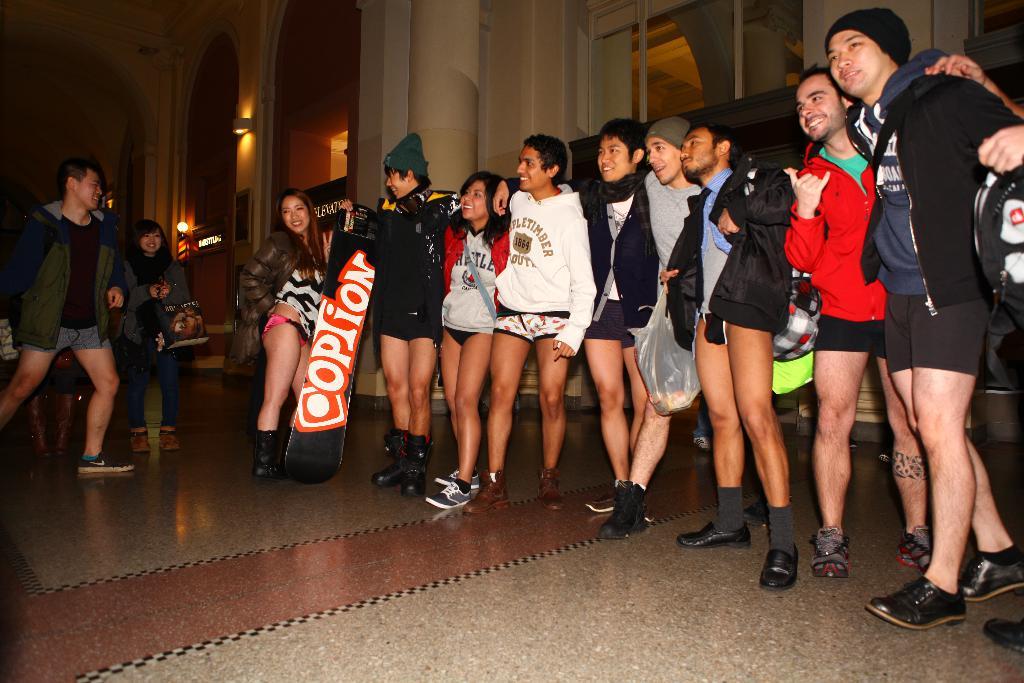What does the white text say on the red background?
Your answer should be compact. Option. 